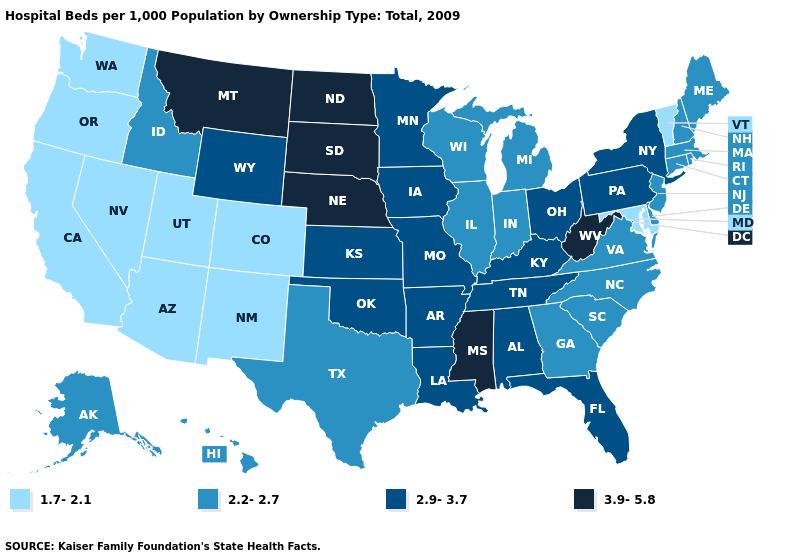What is the value of Washington?
Write a very short answer. 1.7-2.1. What is the lowest value in the West?
Quick response, please. 1.7-2.1. Name the states that have a value in the range 2.9-3.7?
Answer briefly. Alabama, Arkansas, Florida, Iowa, Kansas, Kentucky, Louisiana, Minnesota, Missouri, New York, Ohio, Oklahoma, Pennsylvania, Tennessee, Wyoming. Does Arizona have the same value as Colorado?
Quick response, please. Yes. Name the states that have a value in the range 2.9-3.7?
Answer briefly. Alabama, Arkansas, Florida, Iowa, Kansas, Kentucky, Louisiana, Minnesota, Missouri, New York, Ohio, Oklahoma, Pennsylvania, Tennessee, Wyoming. Name the states that have a value in the range 1.7-2.1?
Keep it brief. Arizona, California, Colorado, Maryland, Nevada, New Mexico, Oregon, Utah, Vermont, Washington. What is the value of Missouri?
Concise answer only. 2.9-3.7. Does Oklahoma have a higher value than Iowa?
Answer briefly. No. What is the value of Florida?
Write a very short answer. 2.9-3.7. Name the states that have a value in the range 1.7-2.1?
Answer briefly. Arizona, California, Colorado, Maryland, Nevada, New Mexico, Oregon, Utah, Vermont, Washington. Name the states that have a value in the range 3.9-5.8?
Write a very short answer. Mississippi, Montana, Nebraska, North Dakota, South Dakota, West Virginia. What is the value of New York?
Answer briefly. 2.9-3.7. Among the states that border Montana , which have the lowest value?
Quick response, please. Idaho. What is the highest value in the USA?
Concise answer only. 3.9-5.8. What is the value of Rhode Island?
Keep it brief. 2.2-2.7. 